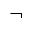<formula> <loc_0><loc_0><loc_500><loc_500>\neg</formula> 